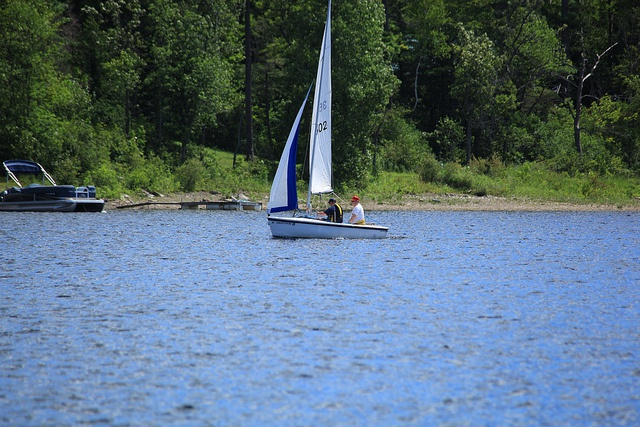Describe the objects in this image and their specific colors. I can see boat in black, gray, darkgray, and navy tones, boat in black, navy, and gray tones, people in black, darkgray, lavender, and brown tones, and people in black, olive, navy, and maroon tones in this image. 